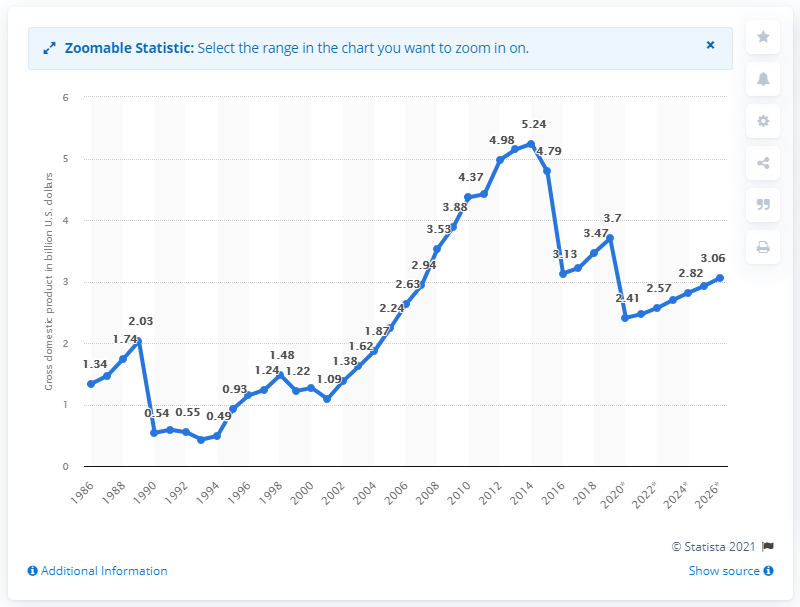List a handful of essential elements in this visual. According to the latest statistics, in 2019, Suriname's gross domestic product was 3.7. 